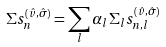<formula> <loc_0><loc_0><loc_500><loc_500>\Sigma s _ { n } ^ { ( \hat { v } , \hat { \sigma } ) } = \sum _ { l } \alpha _ { l } \Sigma _ { l } s _ { n , l } ^ { ( \hat { v } , \hat { \sigma } ) }</formula> 